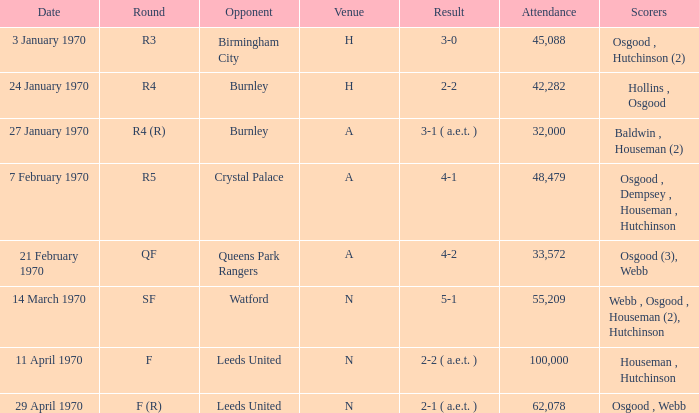What is the highest attendance at a game with a result of 5-1? 55209.0. 